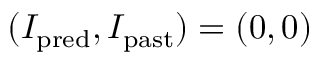Convert formula to latex. <formula><loc_0><loc_0><loc_500><loc_500>( I _ { p r e d } , I _ { p a s t } ) = ( 0 , 0 )</formula> 